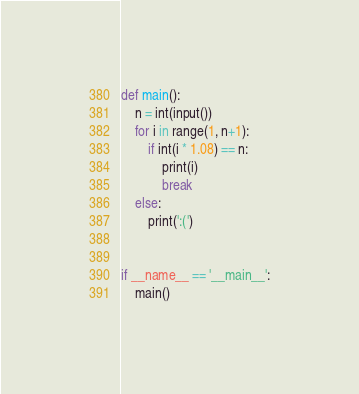Convert code to text. <code><loc_0><loc_0><loc_500><loc_500><_Python_>def main():
    n = int(input())
    for i in range(1, n+1):
        if int(i * 1.08) == n:
            print(i)
            break
    else:
        print(':(')


if __name__ == '__main__':
    main()
</code> 